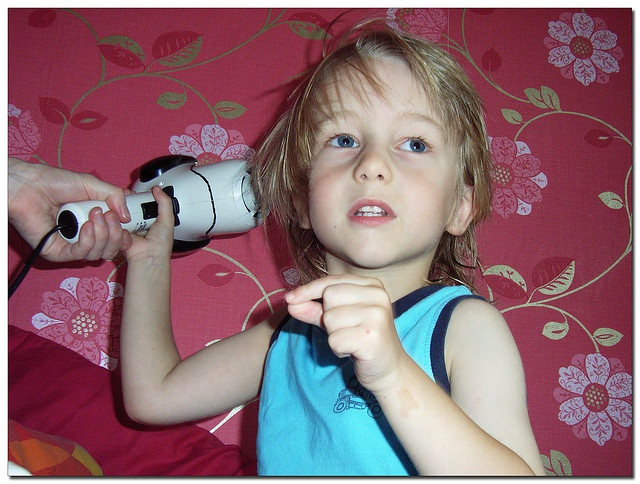Describe the objects in this image and their specific colors. I can see people in white, darkgray, lightgray, maroon, and gray tones, hair drier in white, lightblue, darkgray, black, and gray tones, and people in white, darkgray, gray, and black tones in this image. 